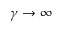Convert formula to latex. <formula><loc_0><loc_0><loc_500><loc_500>\gamma \rightarrow \infty</formula> 